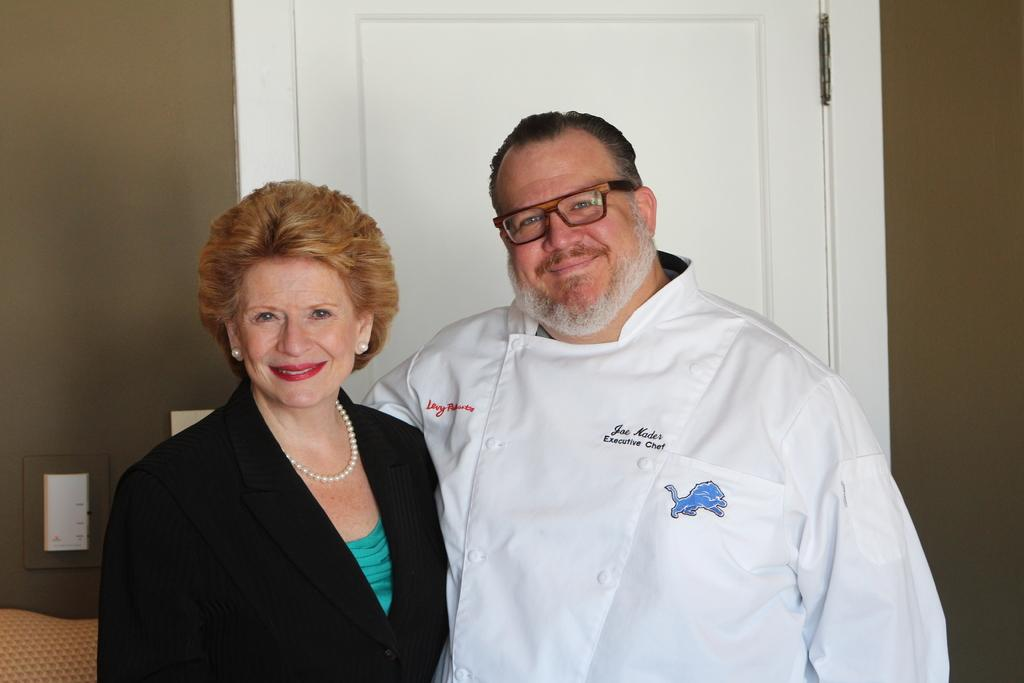How many people are present in the image? There is a man and a woman in the image. What can be seen in the background of the image? There is a door, a wall, and some objects in the background of the image. Can you describe the objects in the background? Unfortunately, the provided facts do not give specific details about the objects in the background. What type of insurance policy does the man in the image have? There is no information about insurance policies in the image. Can you tell me how many skates the woman in the image is wearing? There is no mention of skates or any footwear in the image. 